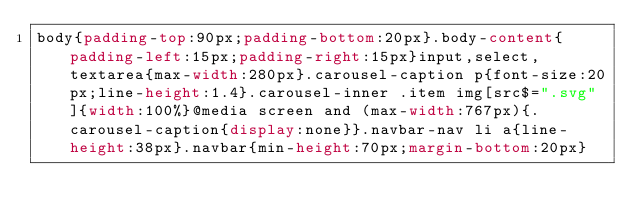<code> <loc_0><loc_0><loc_500><loc_500><_CSS_>body{padding-top:90px;padding-bottom:20px}.body-content{padding-left:15px;padding-right:15px}input,select,textarea{max-width:280px}.carousel-caption p{font-size:20px;line-height:1.4}.carousel-inner .item img[src$=".svg"]{width:100%}@media screen and (max-width:767px){.carousel-caption{display:none}}.navbar-nav li a{line-height:38px}.navbar{min-height:70px;margin-bottom:20px}</code> 